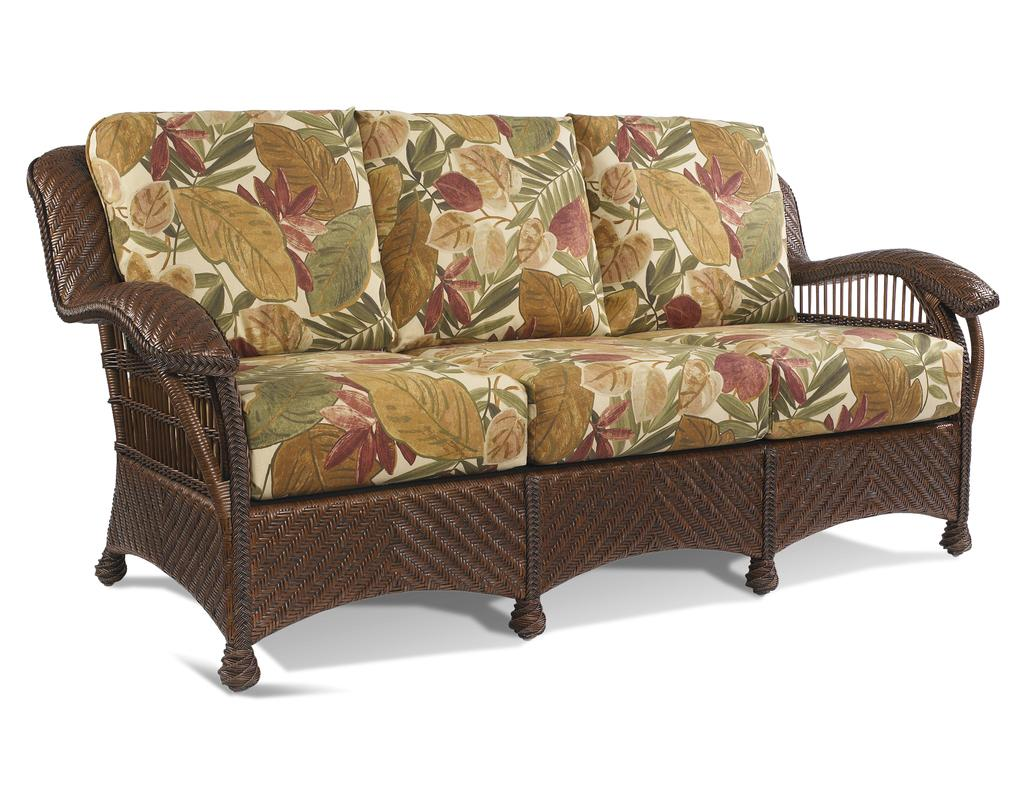What type of furniture is present in the image? There is a sofa in the image. Can you see a carriage being pulled by horses in the image? No, there is no carriage or horses present in the image; it only features a sofa. 